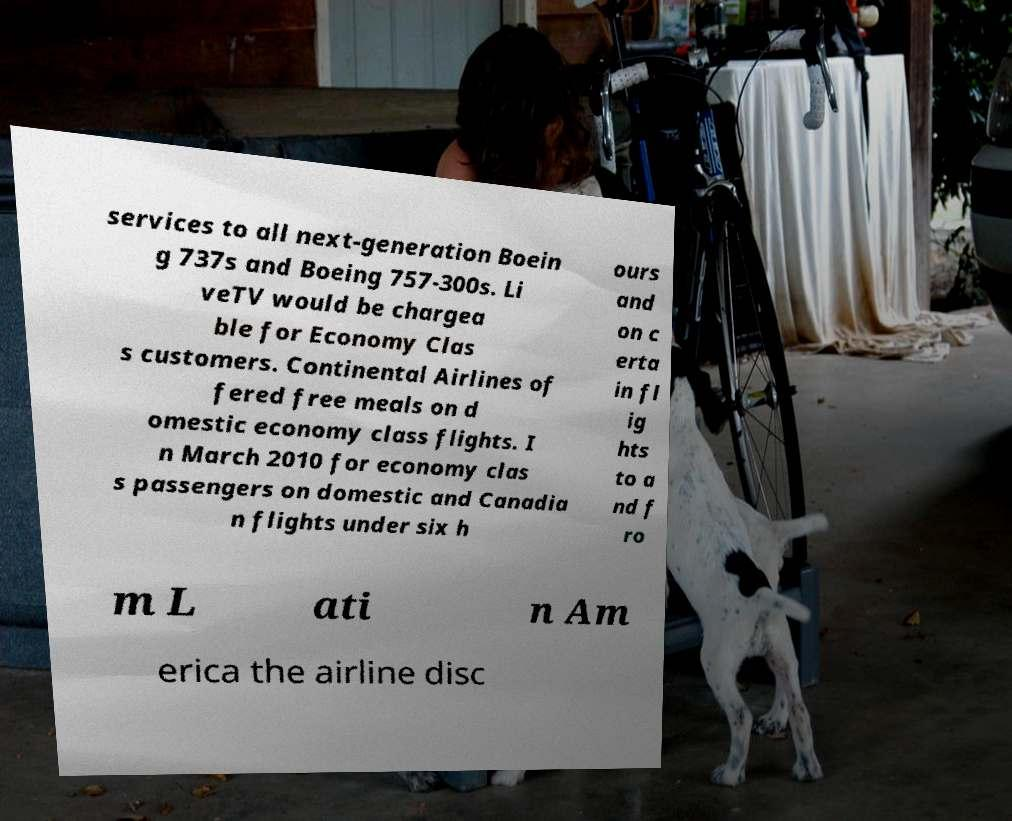Could you assist in decoding the text presented in this image and type it out clearly? services to all next-generation Boein g 737s and Boeing 757-300s. Li veTV would be chargea ble for Economy Clas s customers. Continental Airlines of fered free meals on d omestic economy class flights. I n March 2010 for economy clas s passengers on domestic and Canadia n flights under six h ours and on c erta in fl ig hts to a nd f ro m L ati n Am erica the airline disc 